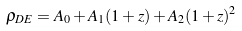<formula> <loc_0><loc_0><loc_500><loc_500>\rho _ { D E } = A _ { 0 } + A _ { 1 } ( 1 + z ) + A _ { 2 } ( 1 + z ) ^ { 2 }</formula> 